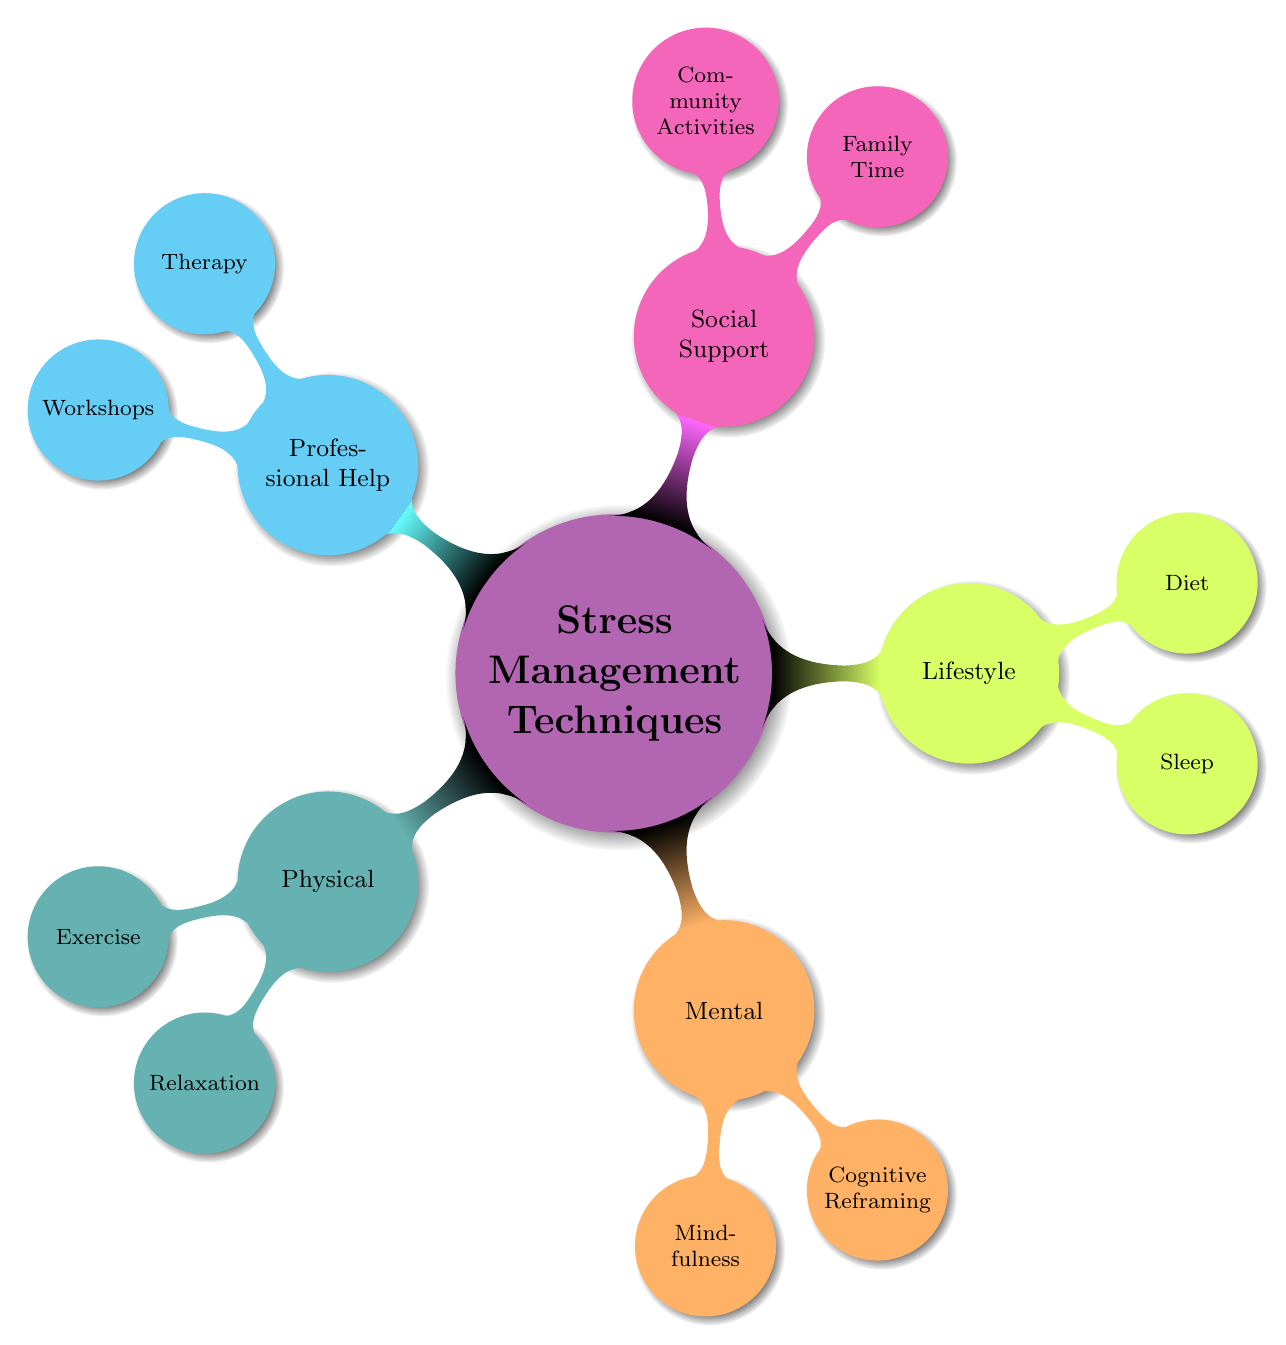What are the five main categories of stress management techniques? The diagram has the root node labeled "Stress Management Techniques," which branches out into five main categories: Physical, Mental, Lifestyle, Social Support, and Professional Help.
Answer: Physical, Mental, Lifestyle, Social Support, Professional Help How many sub-techniques are listed under the Mental category? Under the Mental category in the diagram, there are two sub-techniques listed: Mindfulness and Cognitive Reframing. Therefore, the total count of sub-techniques is 2.
Answer: 2 What is one example of a Professional Help technique? The diagram indicates that under the Professional Help category, one of the sub-techniques presented is Therapy.
Answer: Therapy Which lifestyle technique focuses on sleep? Within the Lifestyle category, the sub-technique relating specifically to sleep is listed as Sleep, which emphasizes maintaining consistent sleep schedules.
Answer: Sleep What type of support is emphasized by spending quality time with loved ones? The diagram indicates that "Family Time" is a sub-technique under the Social Support category, which stresses the importance of spending quality time with loved ones.
Answer: Family Time Which category includes techniques such as deep breathing and Tai Chi? The Relaxation sub-technique, which includes practices such as deep breathing and Tai Chi, is found under the Physical Techniques category.
Answer: Physical Techniques What is the relationship between "Exercise" and "Physical Techniques"? The node "Exercise" is a child node that falls directly under the "Physical Techniques" parent node, indicating that it is one of the sub-techniques associated with managing stress through physical activity.
Answer: Child node name a technique that encourages positive thinking. The Cognitive Reframing sub-technique under the Mental category encompasses techniques aimed at encouraging positive thinking, such as affirmations.
Answer: Cognitive Reframing How many nodes are in the Social Support category? In the Social Support category, there are two child nodes listed: Family Time and Community Activities, resulting in a total of 2 nodes in that category.
Answer: 2 